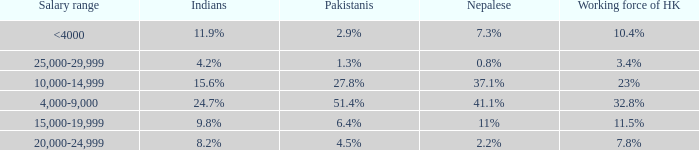If the nepalese is 37.1%, what is the working force of HK? 23%. 